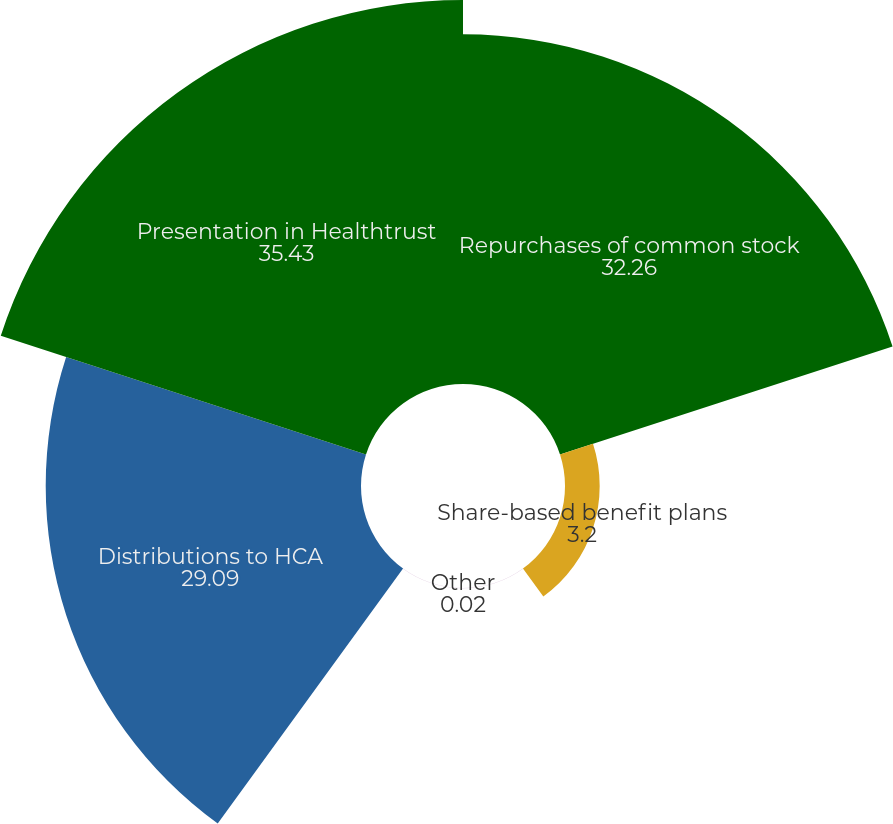Convert chart. <chart><loc_0><loc_0><loc_500><loc_500><pie_chart><fcel>Repurchases of common stock<fcel>Share-based benefit plans<fcel>Other<fcel>Distributions to HCA<fcel>Presentation in Healthtrust<nl><fcel>32.26%<fcel>3.2%<fcel>0.02%<fcel>29.09%<fcel>35.43%<nl></chart> 